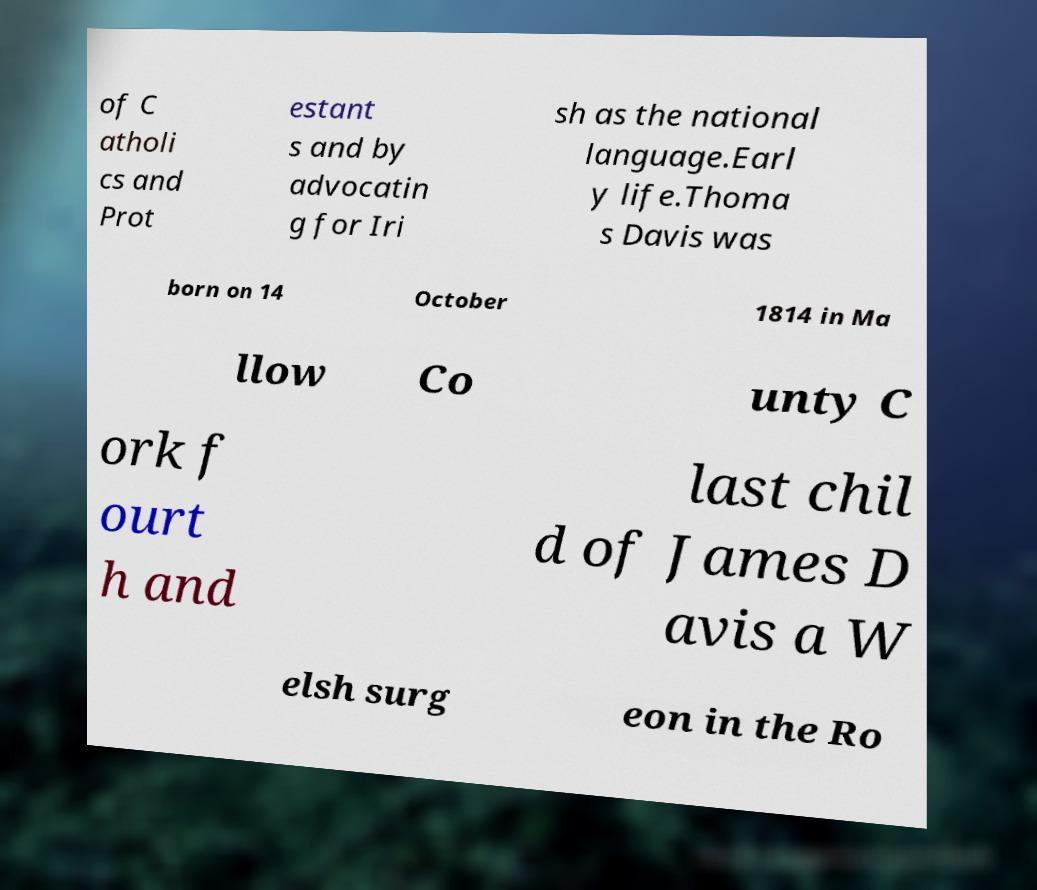Can you accurately transcribe the text from the provided image for me? of C atholi cs and Prot estant s and by advocatin g for Iri sh as the national language.Earl y life.Thoma s Davis was born on 14 October 1814 in Ma llow Co unty C ork f ourt h and last chil d of James D avis a W elsh surg eon in the Ro 